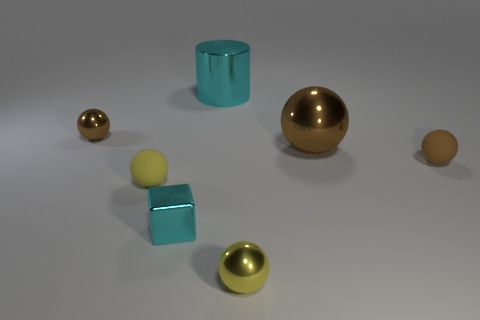How many brown spheres must be subtracted to get 1 brown spheres? 2 Subtract all red cylinders. How many brown spheres are left? 3 Subtract all big metallic balls. How many balls are left? 4 Subtract all blue balls. Subtract all brown cylinders. How many balls are left? 5 Add 3 large brown things. How many objects exist? 10 Subtract all balls. How many objects are left? 2 Add 2 large brown shiny balls. How many large brown shiny balls are left? 3 Add 6 brown matte objects. How many brown matte objects exist? 7 Subtract 0 cyan spheres. How many objects are left? 7 Subtract all tiny cyan rubber cylinders. Subtract all large brown shiny things. How many objects are left? 6 